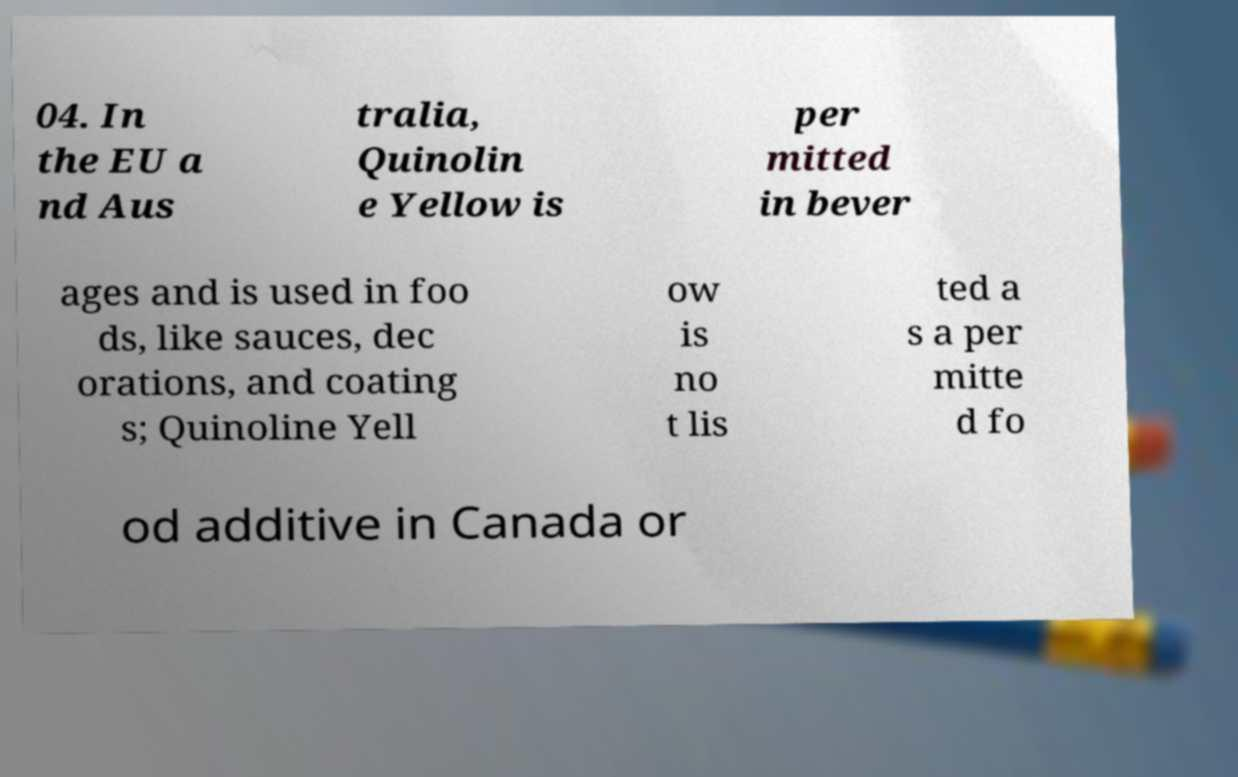Can you accurately transcribe the text from the provided image for me? 04. In the EU a nd Aus tralia, Quinolin e Yellow is per mitted in bever ages and is used in foo ds, like sauces, dec orations, and coating s; Quinoline Yell ow is no t lis ted a s a per mitte d fo od additive in Canada or 